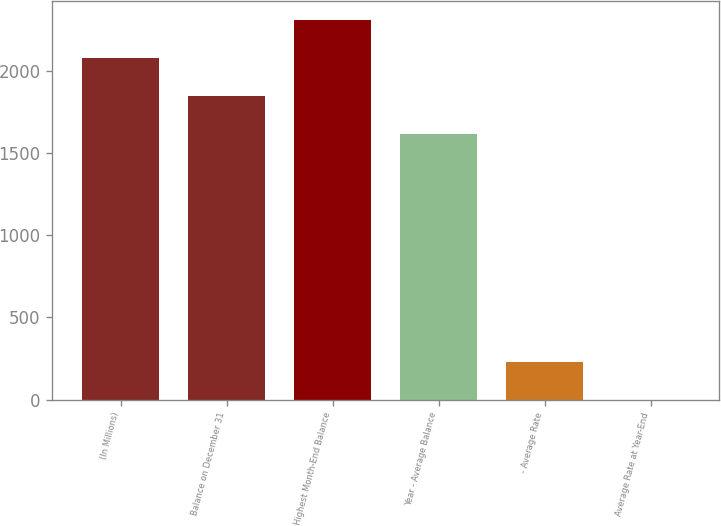Convert chart. <chart><loc_0><loc_0><loc_500><loc_500><bar_chart><fcel>(In Millions)<fcel>Balance on December 31<fcel>Highest Month-End Balance<fcel>Year - Average Balance<fcel>- Average Rate<fcel>Average Rate at Year-End<nl><fcel>2078.84<fcel>1848.07<fcel>2309.61<fcel>1617.3<fcel>230.84<fcel>0.07<nl></chart> 